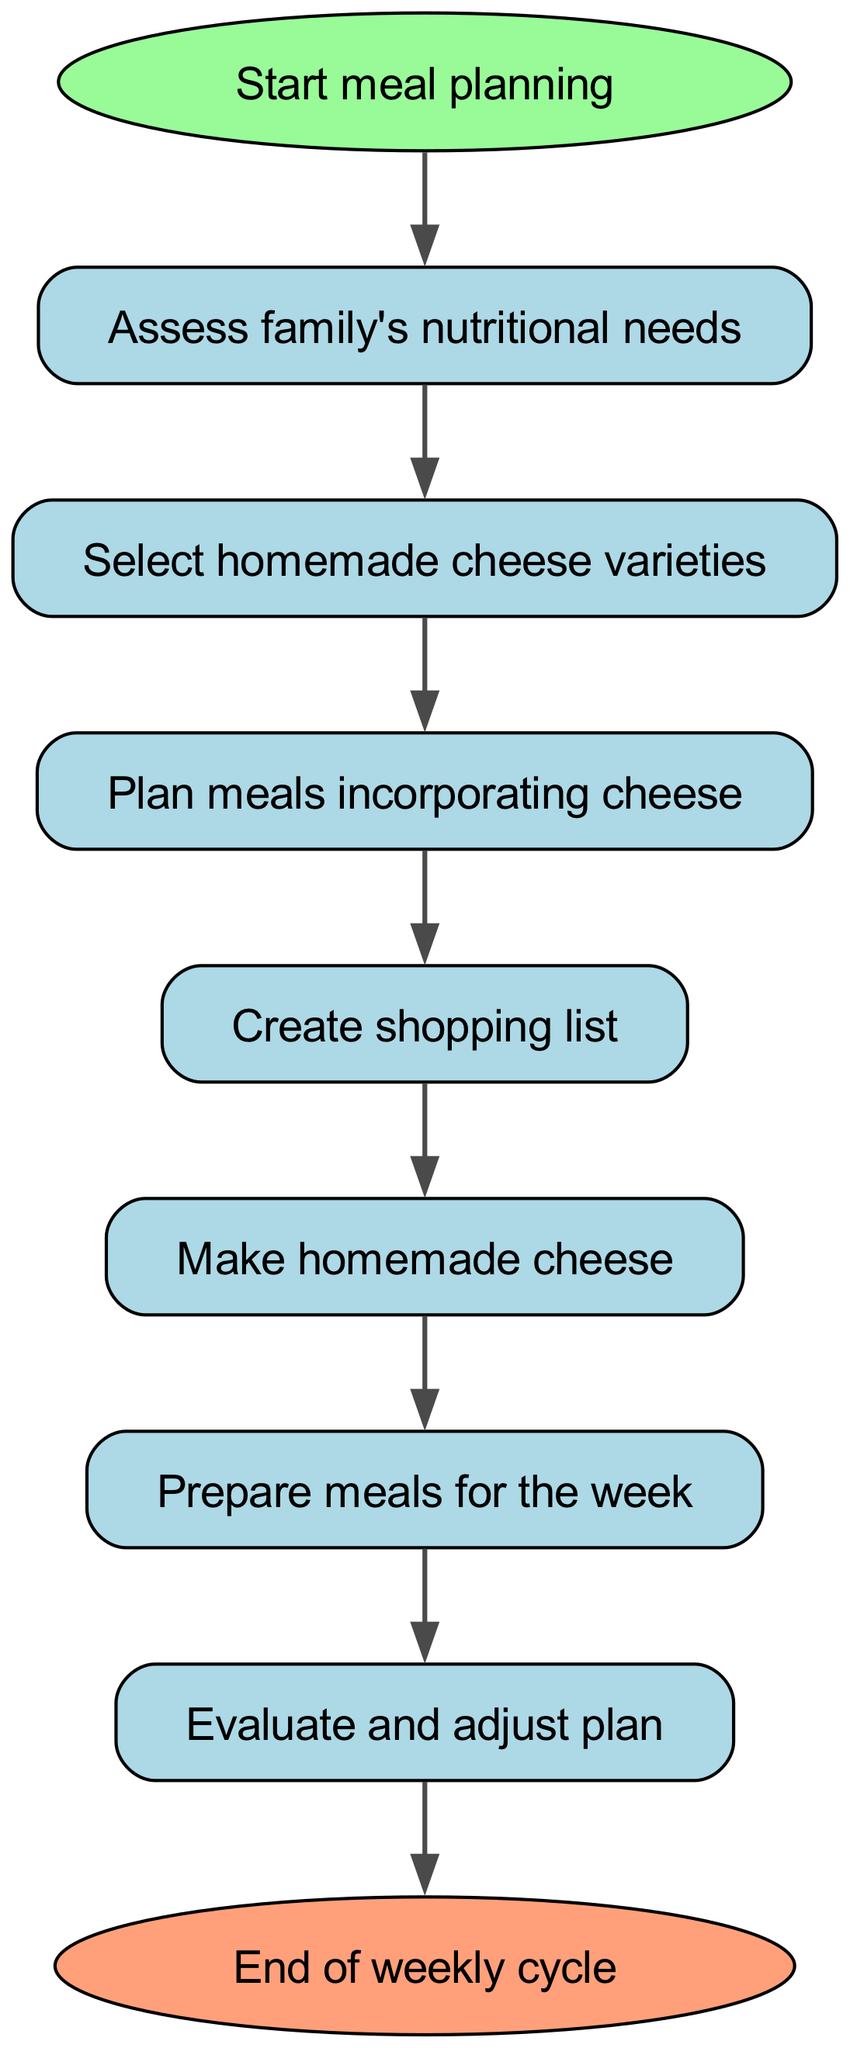What is the first step in the meal planning process? The first step in the diagram is labeled "Start meal planning," indicating it is the initial action to be taken.
Answer: Start meal planning How many steps are there in total from start to end? By counting the boxes, including the start and end nodes, there are a total of 9 steps in the flow chart.
Answer: 9 What follows the step of "Create shopping list"? The step after "Create shopping list" is "Make homemade cheese," as indicated in the flow of the diagram.
Answer: Make homemade cheese Which step comes before "Assess family's nutritional needs"? The diagram shows that there is no step before "Assess family's nutritional needs," as it directly follows the start.
Answer: None What is the last step in the process? The final step in the flow chart is labeled "End of weekly cycle," which signifies the conclusion of the planning cycle.
Answer: End of weekly cycle How many nodes in total involve meal preparation activities? There are four nodes related to meal preparation: "Plan meals incorporating cheese," "Make homemade cheese," "Prepare meals for the week," and "Evaluate and adjust plan."
Answer: 4 What do you do after you "Prepare meals for the week"? According to the diagram, the next step after "Prepare meals for the week" is to "Evaluate and adjust plan."
Answer: Evaluate and adjust plan Which node follows "Select homemade cheese varieties"? The flowchart shows that after "Select homemade cheese varieties," the next step is "Plan meals incorporating cheese."
Answer: Plan meals incorporating cheese What is the relationship between "Evaluate" and "End of weekly cycle"? "Evaluate" is an action that must be completed before reaching "End of weekly cycle," exhibiting a sequential relationship where evaluation leads to the conclusion.
Answer: Sequential relationship 